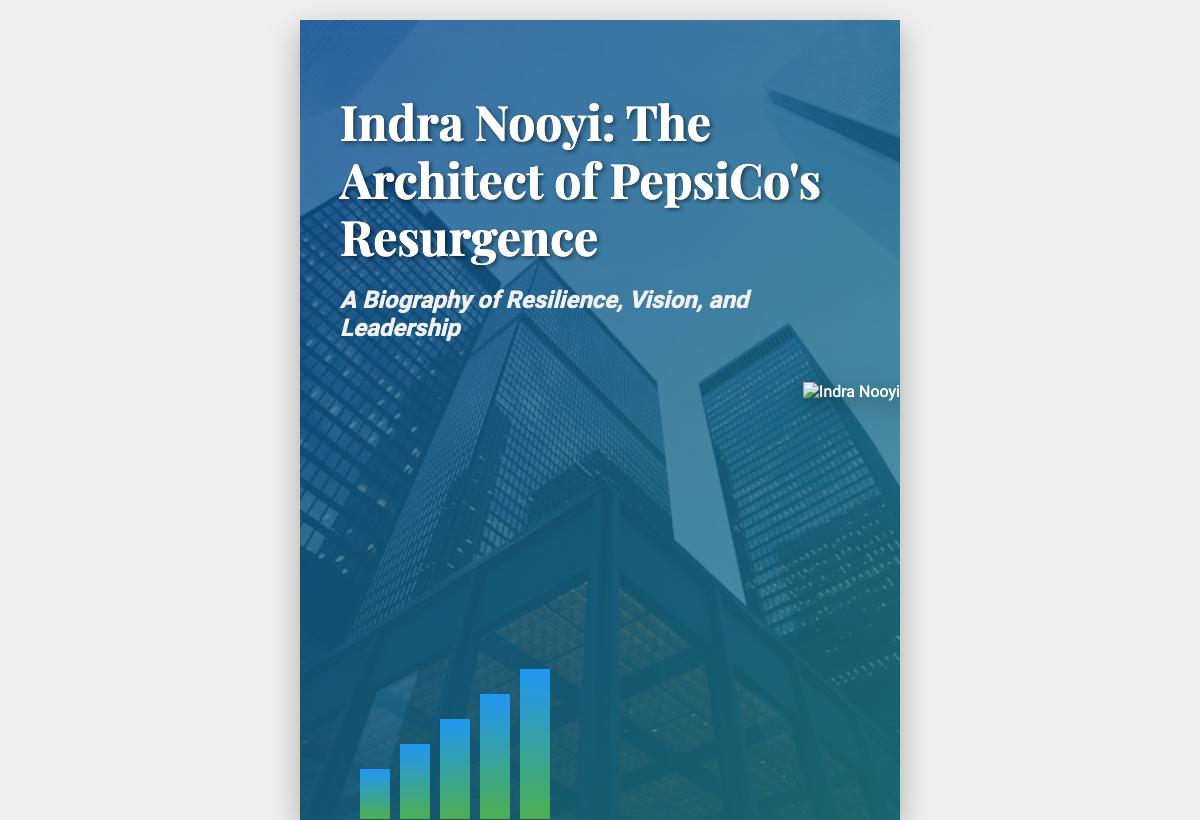What is the title of the book? The title of the book is prominently displayed at the top of the cover.
Answer: Indra Nooyi: The Architect of PepsiCo's Resurgence Who is the author? The author's name is indicated at the bottom of the cover.
Answer: By [Your Name] What does the subtitle describe? The subtitle provides insight into the themes of the biography.
Answer: A Biography of Resilience, Vision, and Leadership What color is the background gradient? The background features a specific color scheme, which can be identified by looking at the cover.
Answer: Blue and Green What figure is represented as rising in the background? The graphical representation in the background depicts a specific visualization.
Answer: Bar graph How many bars are in the graph? The number of bars displayed in the graph can be counted visually.
Answer: Five bars What is the dominant theme of the biography? The main theme is highlighted within the subtitle, implying the traits of the subject.
Answer: Resilience What is depicted in the image of Indra Nooyi? The image serves a specific purpose in the context of the biography, linking to her identity.
Answer: Leadership What professional role does Indra Nooyi represent? The professional identity of the figure shown is inferred from the context of the cover.
Answer: Business Executive 